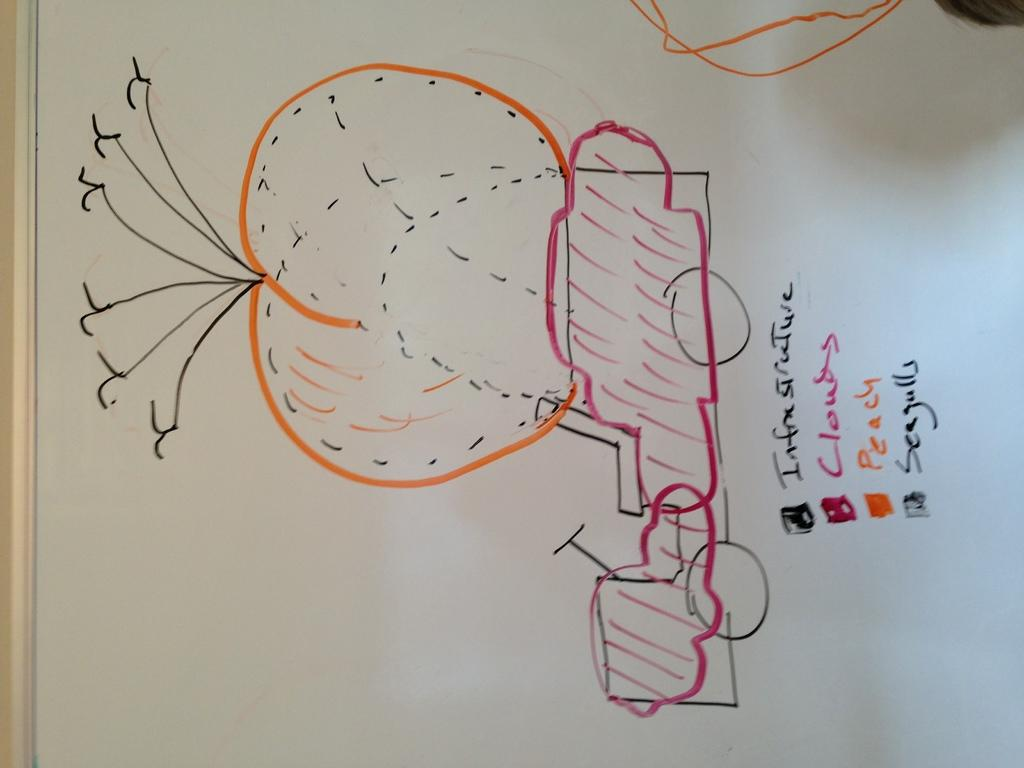<image>
Render a clear and concise summary of the photo. A whiteboard on its side has the word seagulls on it. 